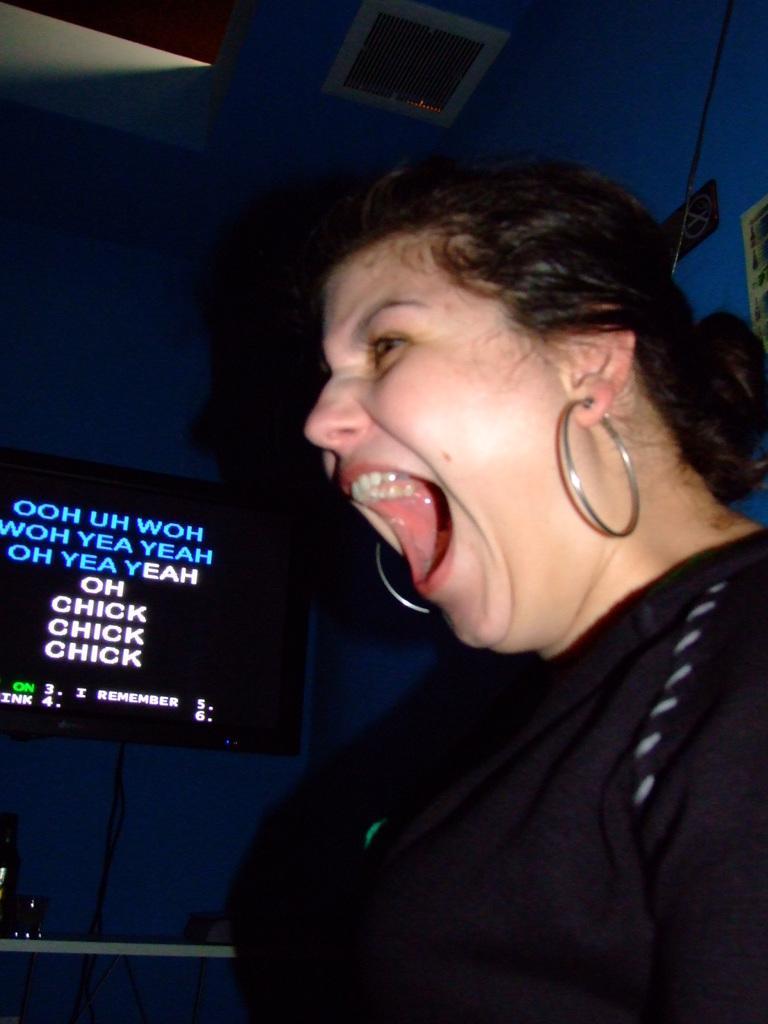Can you describe this image briefly? In this image we can see a person mouth open and wearing the black dress and there is a television in this picture. 